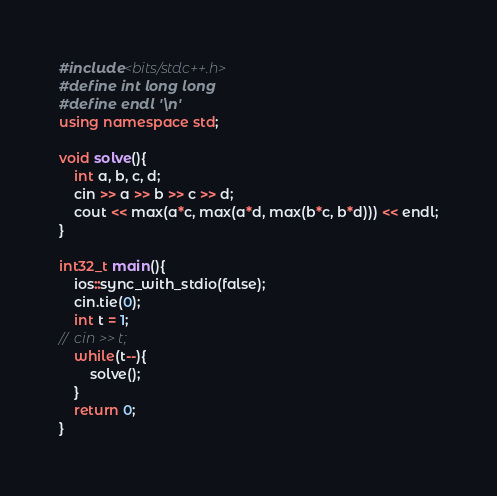<code> <loc_0><loc_0><loc_500><loc_500><_C++_>#include<bits/stdc++.h>
#define int long long
#define endl '\n'
using namespace std;

void solve(){
	int a, b, c, d;
	cin >> a >> b >> c >> d;
	cout << max(a*c, max(a*d, max(b*c, b*d))) << endl;
}

int32_t main(){
	ios::sync_with_stdio(false);
	cin.tie(0);
	int t = 1;
//	cin >> t;
	while(t--){
		solve();
	}
	return 0;
}
</code> 